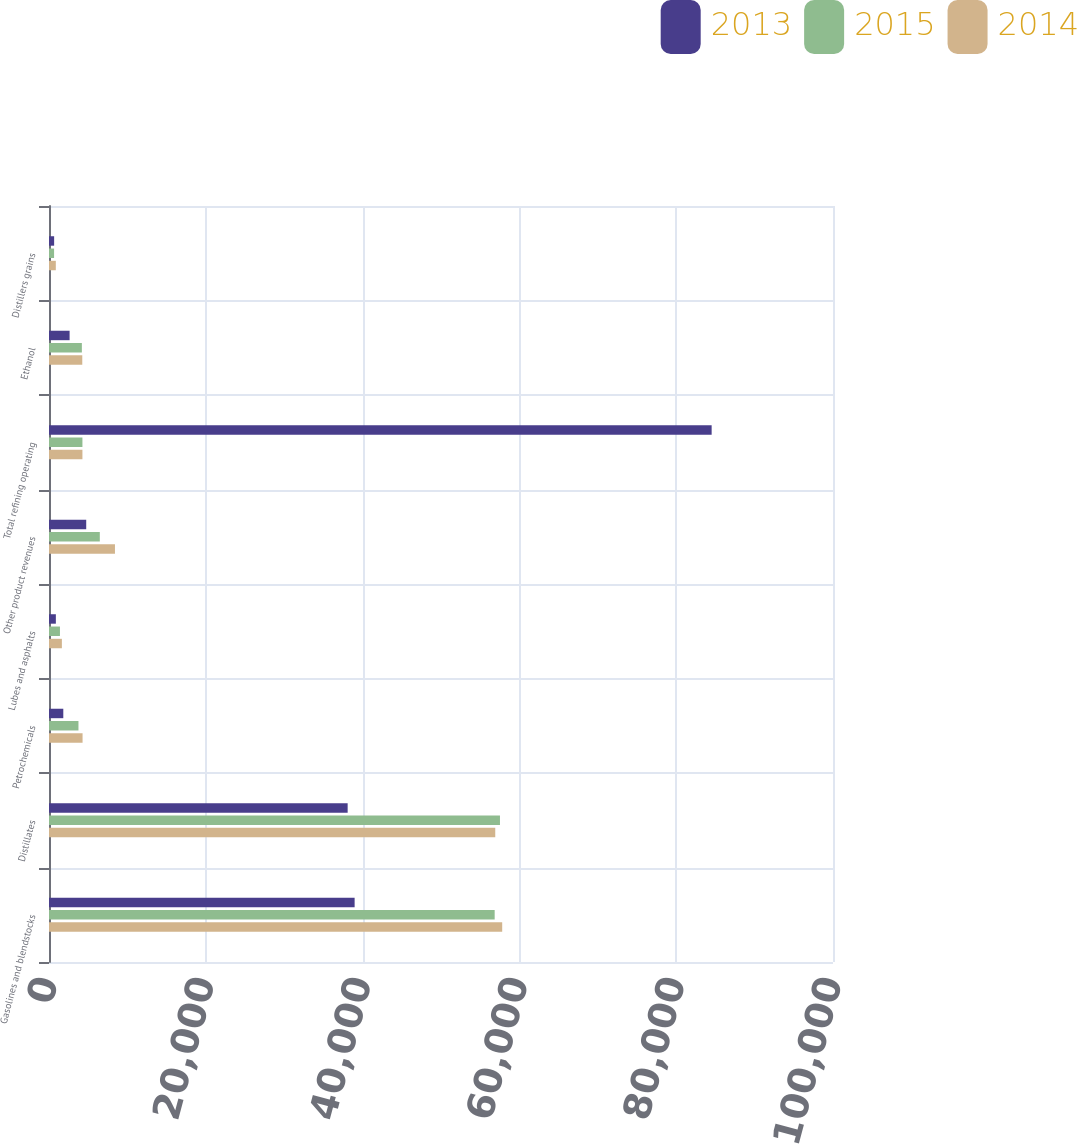Convert chart. <chart><loc_0><loc_0><loc_500><loc_500><stacked_bar_chart><ecel><fcel>Gasolines and blendstocks<fcel>Distillates<fcel>Petrochemicals<fcel>Lubes and asphalts<fcel>Other product revenues<fcel>Total refining operating<fcel>Ethanol<fcel>Distillers grains<nl><fcel>2013<fcel>38983<fcel>38093<fcel>1824<fcel>874<fcel>4747<fcel>84521<fcel>2628<fcel>655<nl><fcel>2015<fcel>56846<fcel>57521<fcel>3759<fcel>1397<fcel>6481<fcel>4263<fcel>4192<fcel>648<nl><fcel>2014<fcel>57806<fcel>56921<fcel>4281<fcel>1643<fcel>8413<fcel>4263<fcel>4245<fcel>869<nl></chart> 